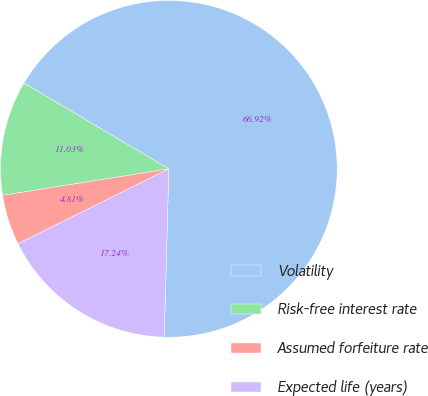<chart> <loc_0><loc_0><loc_500><loc_500><pie_chart><fcel>Volatility<fcel>Risk-free interest rate<fcel>Assumed forfeiture rate<fcel>Expected life (years)<nl><fcel>66.92%<fcel>11.03%<fcel>4.81%<fcel>17.24%<nl></chart> 